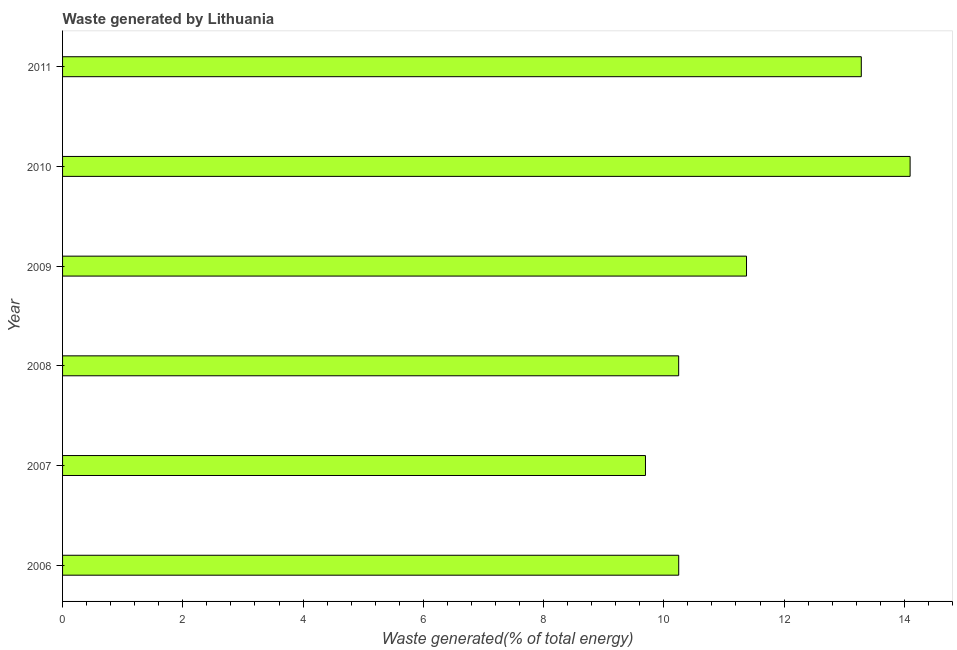Does the graph contain any zero values?
Ensure brevity in your answer.  No. What is the title of the graph?
Ensure brevity in your answer.  Waste generated by Lithuania. What is the label or title of the X-axis?
Offer a terse response. Waste generated(% of total energy). What is the label or title of the Y-axis?
Keep it short and to the point. Year. What is the amount of waste generated in 2010?
Ensure brevity in your answer.  14.1. Across all years, what is the maximum amount of waste generated?
Your response must be concise. 14.1. Across all years, what is the minimum amount of waste generated?
Provide a short and direct response. 9.69. In which year was the amount of waste generated minimum?
Provide a short and direct response. 2007. What is the sum of the amount of waste generated?
Provide a succinct answer. 68.94. What is the difference between the amount of waste generated in 2007 and 2011?
Ensure brevity in your answer.  -3.59. What is the average amount of waste generated per year?
Offer a very short reply. 11.49. What is the median amount of waste generated?
Keep it short and to the point. 10.81. Do a majority of the years between 2009 and 2010 (inclusive) have amount of waste generated greater than 9.2 %?
Your answer should be compact. Yes. What is the ratio of the amount of waste generated in 2007 to that in 2009?
Give a very brief answer. 0.85. Is the amount of waste generated in 2006 less than that in 2008?
Keep it short and to the point. No. What is the difference between the highest and the second highest amount of waste generated?
Ensure brevity in your answer.  0.81. What is the difference between the highest and the lowest amount of waste generated?
Keep it short and to the point. 4.4. In how many years, is the amount of waste generated greater than the average amount of waste generated taken over all years?
Ensure brevity in your answer.  2. How many bars are there?
Provide a succinct answer. 6. How many years are there in the graph?
Keep it short and to the point. 6. What is the difference between two consecutive major ticks on the X-axis?
Your answer should be compact. 2. What is the Waste generated(% of total energy) in 2006?
Offer a terse response. 10.25. What is the Waste generated(% of total energy) in 2007?
Your answer should be compact. 9.69. What is the Waste generated(% of total energy) of 2008?
Make the answer very short. 10.25. What is the Waste generated(% of total energy) in 2009?
Your response must be concise. 11.38. What is the Waste generated(% of total energy) in 2010?
Offer a terse response. 14.1. What is the Waste generated(% of total energy) in 2011?
Ensure brevity in your answer.  13.28. What is the difference between the Waste generated(% of total energy) in 2006 and 2007?
Provide a succinct answer. 0.55. What is the difference between the Waste generated(% of total energy) in 2006 and 2008?
Ensure brevity in your answer.  0. What is the difference between the Waste generated(% of total energy) in 2006 and 2009?
Your answer should be compact. -1.13. What is the difference between the Waste generated(% of total energy) in 2006 and 2010?
Provide a short and direct response. -3.85. What is the difference between the Waste generated(% of total energy) in 2006 and 2011?
Your response must be concise. -3.04. What is the difference between the Waste generated(% of total energy) in 2007 and 2008?
Your answer should be very brief. -0.55. What is the difference between the Waste generated(% of total energy) in 2007 and 2009?
Your response must be concise. -1.68. What is the difference between the Waste generated(% of total energy) in 2007 and 2010?
Keep it short and to the point. -4.4. What is the difference between the Waste generated(% of total energy) in 2007 and 2011?
Keep it short and to the point. -3.59. What is the difference between the Waste generated(% of total energy) in 2008 and 2009?
Your answer should be compact. -1.13. What is the difference between the Waste generated(% of total energy) in 2008 and 2010?
Ensure brevity in your answer.  -3.85. What is the difference between the Waste generated(% of total energy) in 2008 and 2011?
Give a very brief answer. -3.04. What is the difference between the Waste generated(% of total energy) in 2009 and 2010?
Offer a very short reply. -2.72. What is the difference between the Waste generated(% of total energy) in 2009 and 2011?
Give a very brief answer. -1.91. What is the difference between the Waste generated(% of total energy) in 2010 and 2011?
Keep it short and to the point. 0.81. What is the ratio of the Waste generated(% of total energy) in 2006 to that in 2007?
Keep it short and to the point. 1.06. What is the ratio of the Waste generated(% of total energy) in 2006 to that in 2008?
Keep it short and to the point. 1. What is the ratio of the Waste generated(% of total energy) in 2006 to that in 2009?
Give a very brief answer. 0.9. What is the ratio of the Waste generated(% of total energy) in 2006 to that in 2010?
Offer a very short reply. 0.73. What is the ratio of the Waste generated(% of total energy) in 2006 to that in 2011?
Provide a succinct answer. 0.77. What is the ratio of the Waste generated(% of total energy) in 2007 to that in 2008?
Provide a short and direct response. 0.95. What is the ratio of the Waste generated(% of total energy) in 2007 to that in 2009?
Provide a short and direct response. 0.85. What is the ratio of the Waste generated(% of total energy) in 2007 to that in 2010?
Provide a succinct answer. 0.69. What is the ratio of the Waste generated(% of total energy) in 2007 to that in 2011?
Your answer should be compact. 0.73. What is the ratio of the Waste generated(% of total energy) in 2008 to that in 2009?
Ensure brevity in your answer.  0.9. What is the ratio of the Waste generated(% of total energy) in 2008 to that in 2010?
Provide a short and direct response. 0.73. What is the ratio of the Waste generated(% of total energy) in 2008 to that in 2011?
Your answer should be compact. 0.77. What is the ratio of the Waste generated(% of total energy) in 2009 to that in 2010?
Your answer should be compact. 0.81. What is the ratio of the Waste generated(% of total energy) in 2009 to that in 2011?
Your answer should be very brief. 0.86. What is the ratio of the Waste generated(% of total energy) in 2010 to that in 2011?
Make the answer very short. 1.06. 